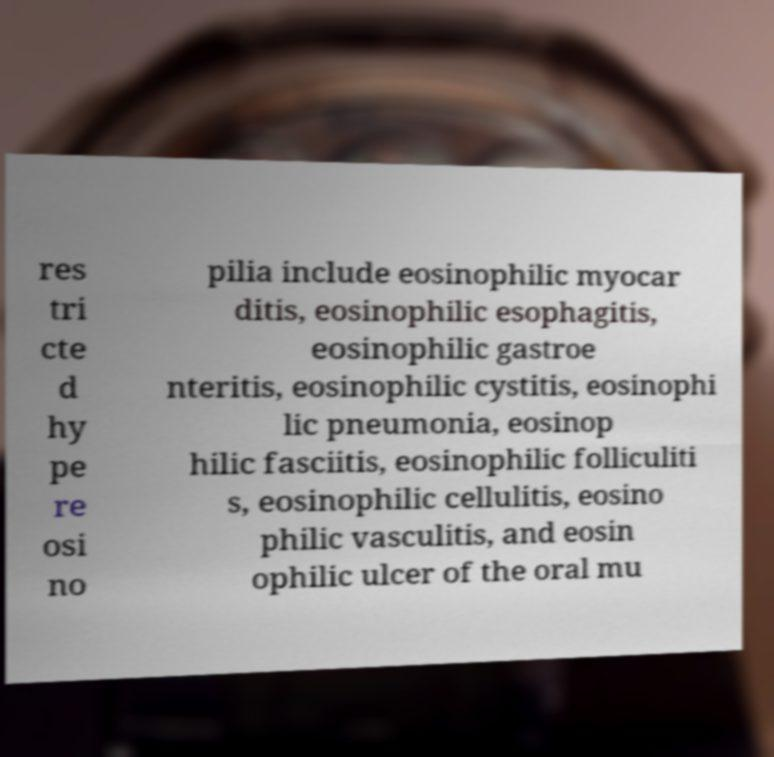Could you assist in decoding the text presented in this image and type it out clearly? res tri cte d hy pe re osi no pilia include eosinophilic myocar ditis, eosinophilic esophagitis, eosinophilic gastroe nteritis, eosinophilic cystitis, eosinophi lic pneumonia, eosinop hilic fasciitis, eosinophilic folliculiti s, eosinophilic cellulitis, eosino philic vasculitis, and eosin ophilic ulcer of the oral mu 